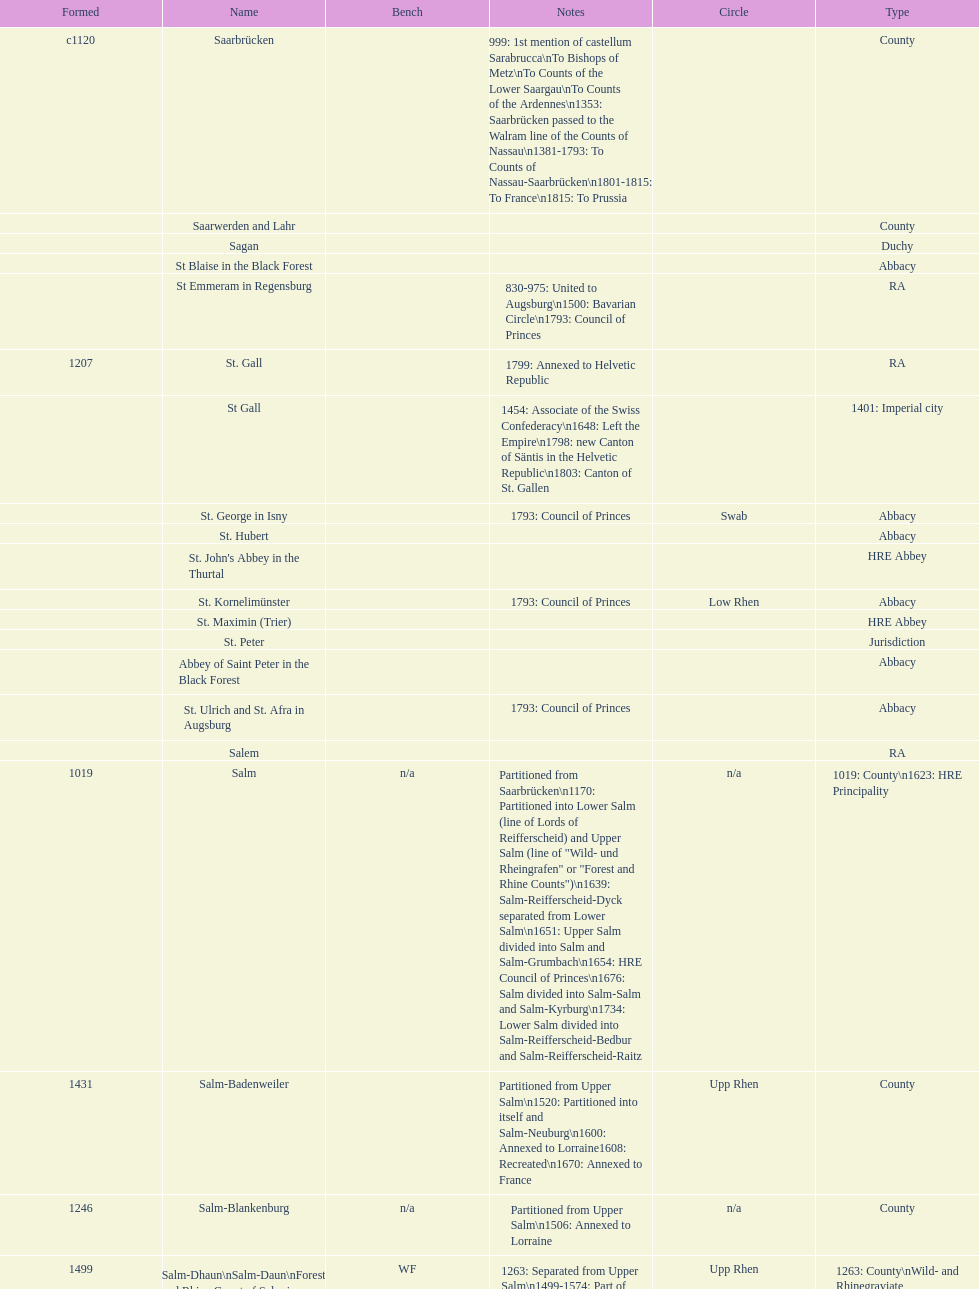Which bench is represented the most? PR. 